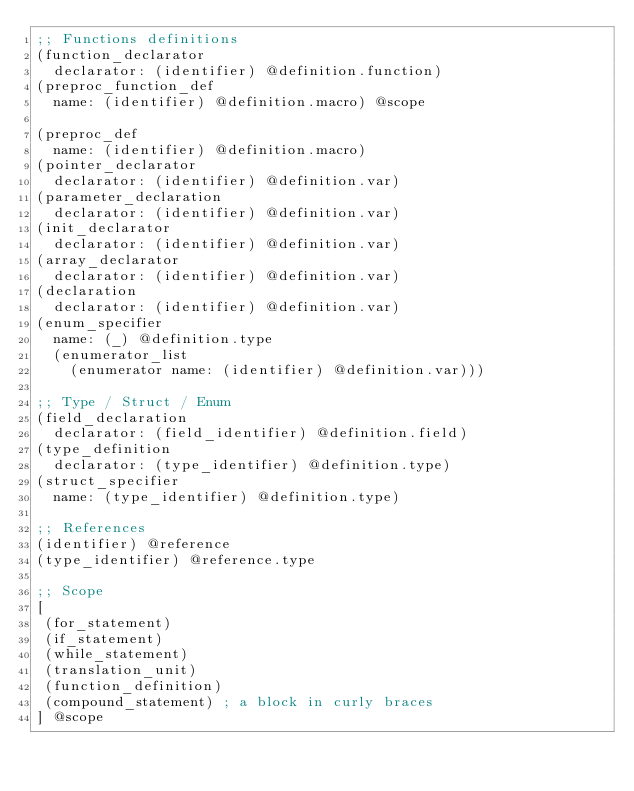<code> <loc_0><loc_0><loc_500><loc_500><_Scheme_>;; Functions definitions
(function_declarator
  declarator: (identifier) @definition.function)
(preproc_function_def
  name: (identifier) @definition.macro) @scope

(preproc_def
  name: (identifier) @definition.macro)
(pointer_declarator
  declarator: (identifier) @definition.var)
(parameter_declaration
  declarator: (identifier) @definition.var)
(init_declarator
  declarator: (identifier) @definition.var)
(array_declarator
  declarator: (identifier) @definition.var)
(declaration
  declarator: (identifier) @definition.var)
(enum_specifier
  name: (_) @definition.type
  (enumerator_list
    (enumerator name: (identifier) @definition.var)))

;; Type / Struct / Enum
(field_declaration
  declarator: (field_identifier) @definition.field)
(type_definition
  declarator: (type_identifier) @definition.type)
(struct_specifier
  name: (type_identifier) @definition.type)

;; References
(identifier) @reference
(type_identifier) @reference.type

;; Scope
[
 (for_statement)
 (if_statement)
 (while_statement)
 (translation_unit)
 (function_definition)
 (compound_statement) ; a block in curly braces
] @scope
</code> 